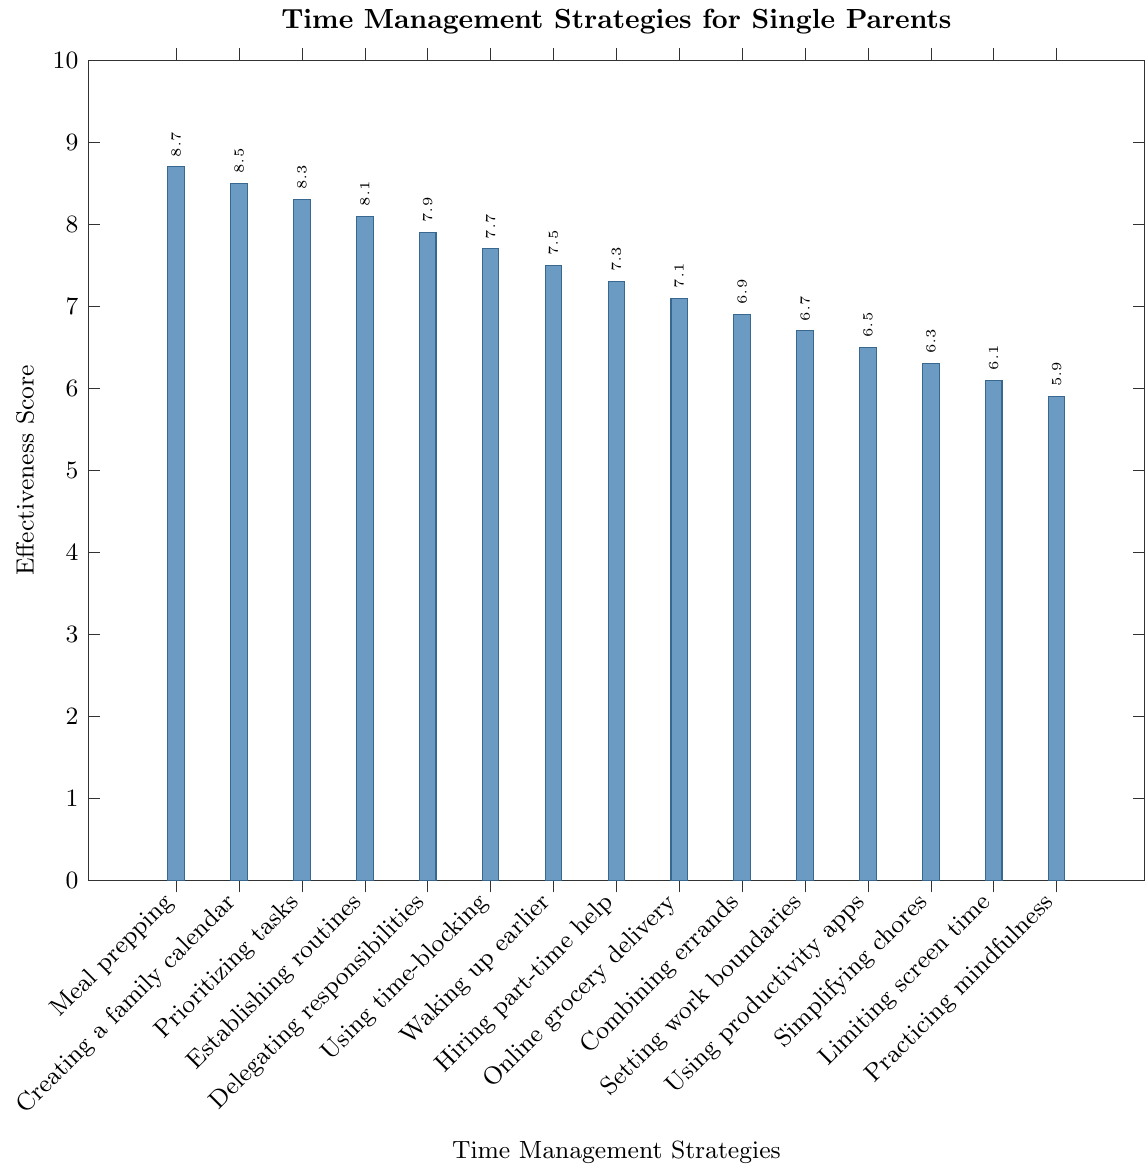What's the most effective time management strategy used by single parents? To determine the most effective time management strategy, observe the bar with the highest effectiveness score. Meal prepping has the highest score at 8.7.
Answer: Meal prepping Which strategy ranks second in effectiveness? Look at the bar with the second-highest effectiveness score. Creating a family calendar has the second-highest score at 8.5.
Answer: Creating a family calendar How much more effective is Meal prepping compared to Practicing mindfulness to reduce stress? Subtract the effectiveness score of Practicing mindfulness (5.9) from the score of Meal prepping (8.7). The difference is 8.7 - 5.9 = 2.8.
Answer: 2.8 What is the effectiveness score of using time-blocking techniques? Find the bar labeled "Using time-blocking techniques" and read its effectiveness score. It is 7.7.
Answer: 7.7 Which strategies have an effectiveness score greater than 8? Identify bars with scores above 8: Meal prepping (8.7), Creating a family calendar (8.5), Prioritizing tasks (8.3), and Establishing routines (8.1).
Answer: Meal prepping, Creating a family calendar, Prioritizing tasks, Establishing routines What is the average effectiveness score of the top three strategies? The top three strategies are Meal prepping (8.7), Creating a family calendar (8.5), and Prioritizing tasks (8.3). Calculate their average: (8.7 + 8.5 + 8.3) / 3 = 8.5.
Answer: 8.5 Which strategy is least effective? Find the bar with the lowest effectiveness score. Practicing mindfulness to reduce stress has the lowest score at 5.9.
Answer: Practicing mindfulness to reduce stress How much more effective is Delegating responsibilities to children compared to Simplifying household chores? Subtract the effectiveness score of Simplifying household chores (6.3) from the score of Delegating responsibilities (7.9). The difference is 7.9 - 6.3 = 1.6.
Answer: 1.6 What is the effectiveness score range observed in the chart? Find the difference between the highest effectiveness score (8.7 for Meal prepping) and the lowest score (5.9 for Practicing mindfulness). The range is 8.7 - 5.9 = 2.8.
Answer: 2.8 Compare the effectiveness of Limiting screen time for both parent and children with Using productivity apps. Which is more effective? Limiting screen time has a score of 6.1, and Using productivity apps has a score of 6.5. Using productivity apps is more effective.
Answer: Using productivity apps 